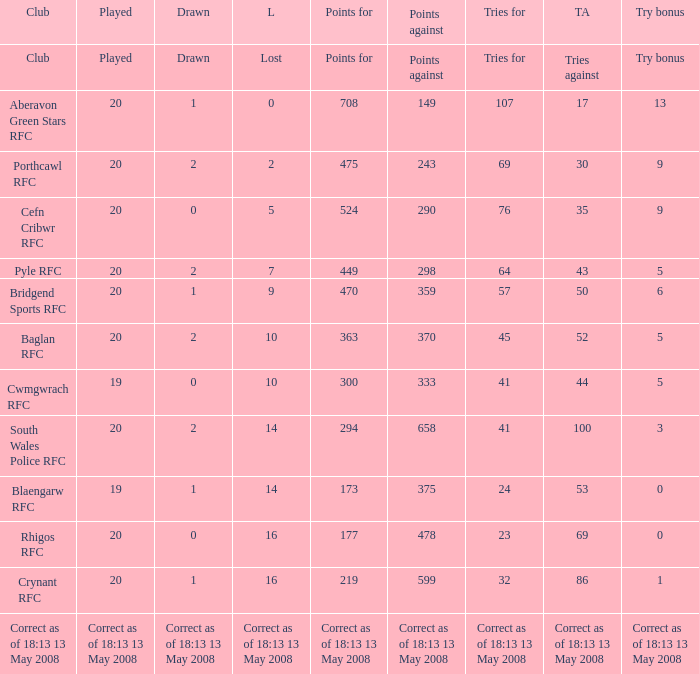What club has a played number of 19, and the lost of 14? Blaengarw RFC. 